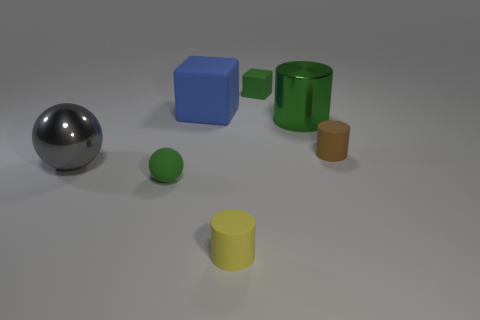What size is the rubber object that is left of the big blue block?
Your response must be concise. Small. There is a cylinder that is on the right side of the large green shiny cylinder; what number of metal objects are behind it?
Make the answer very short. 1. There is a shiny object to the left of the green shiny thing; is its shape the same as the small thing that is on the right side of the small cube?
Ensure brevity in your answer.  No. How many small things are both in front of the green metallic thing and to the left of the metal cylinder?
Your answer should be compact. 2. Is there a tiny rubber block that has the same color as the tiny ball?
Your answer should be very brief. Yes. The shiny object that is the same size as the green cylinder is what shape?
Offer a terse response. Sphere. Are there any large metal things right of the big blue rubber thing?
Provide a short and direct response. Yes. Is the material of the tiny cylinder in front of the large ball the same as the ball that is on the left side of the small green rubber sphere?
Your answer should be compact. No. How many blue matte blocks are the same size as the yellow cylinder?
Provide a short and direct response. 0. There is a metallic object that is the same color as the rubber sphere; what shape is it?
Your response must be concise. Cylinder. 